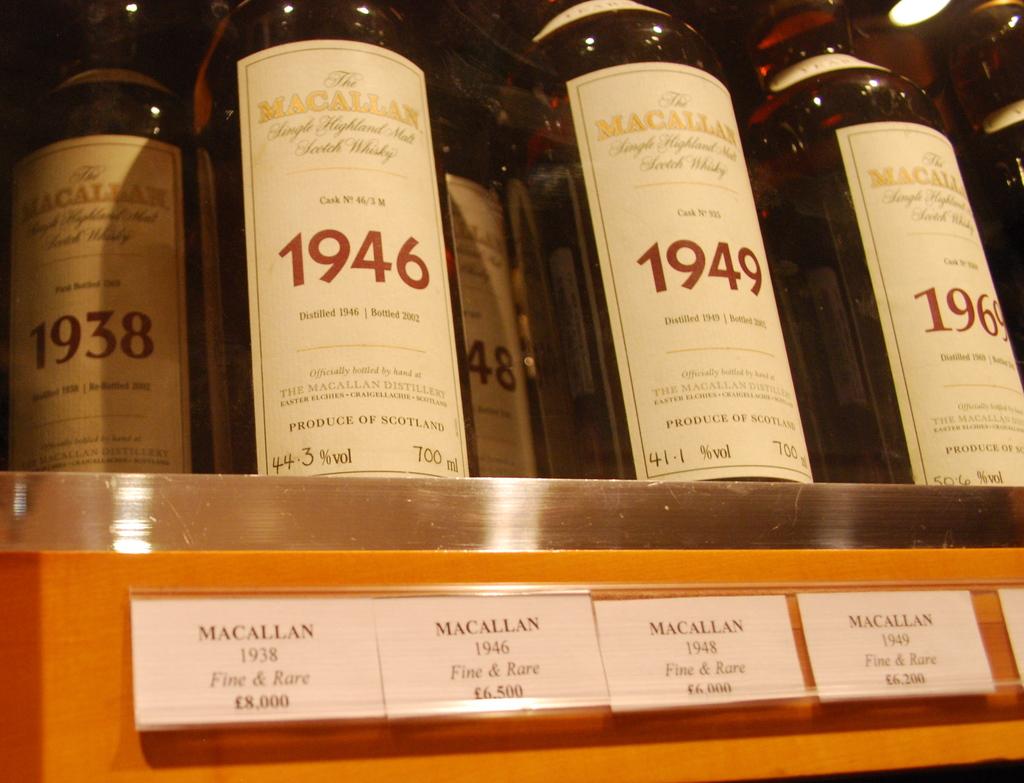Are these different kinds of whiskeys?
Your response must be concise. Yes. What is the oldest year of whiskey?
Your response must be concise. 1938. 